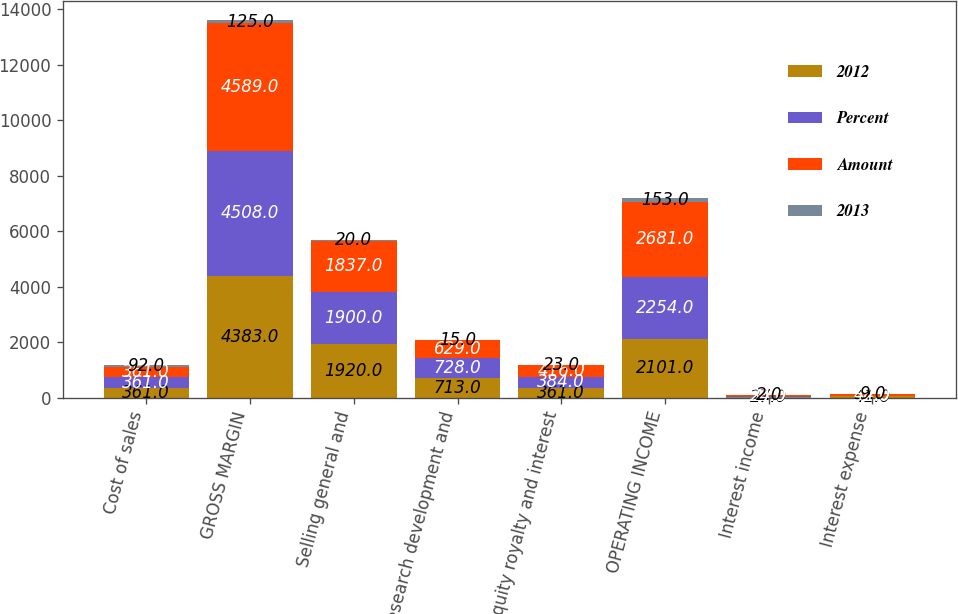Convert chart to OTSL. <chart><loc_0><loc_0><loc_500><loc_500><stacked_bar_chart><ecel><fcel>Cost of sales<fcel>GROSS MARGIN<fcel>Selling general and<fcel>Research development and<fcel>Equity royalty and interest<fcel>OPERATING INCOME<fcel>Interest income<fcel>Interest expense<nl><fcel>2012<fcel>361<fcel>4383<fcel>1920<fcel>713<fcel>361<fcel>2101<fcel>27<fcel>41<nl><fcel>Percent<fcel>361<fcel>4508<fcel>1900<fcel>728<fcel>384<fcel>2254<fcel>25<fcel>32<nl><fcel>Amount<fcel>361<fcel>4589<fcel>1837<fcel>629<fcel>416<fcel>2681<fcel>34<fcel>44<nl><fcel>2013<fcel>92<fcel>125<fcel>20<fcel>15<fcel>23<fcel>153<fcel>2<fcel>9<nl></chart> 